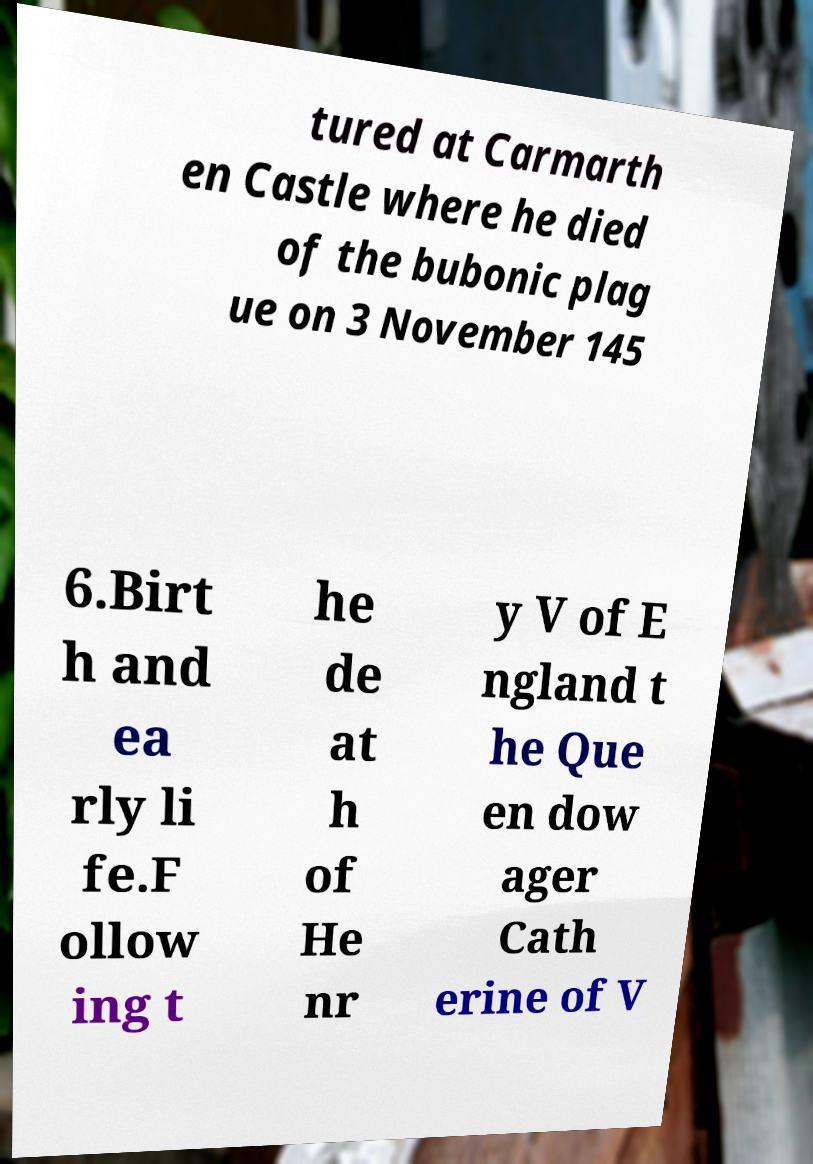Could you extract and type out the text from this image? tured at Carmarth en Castle where he died of the bubonic plag ue on 3 November 145 6.Birt h and ea rly li fe.F ollow ing t he de at h of He nr y V of E ngland t he Que en dow ager Cath erine of V 